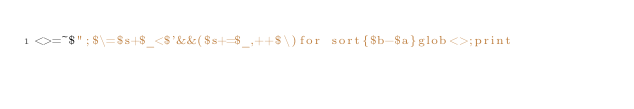Convert code to text. <code><loc_0><loc_0><loc_500><loc_500><_Perl_><>=~$";$\=$s+$_<$'&&($s+=$_,++$\)for sort{$b-$a}glob<>;print</code> 